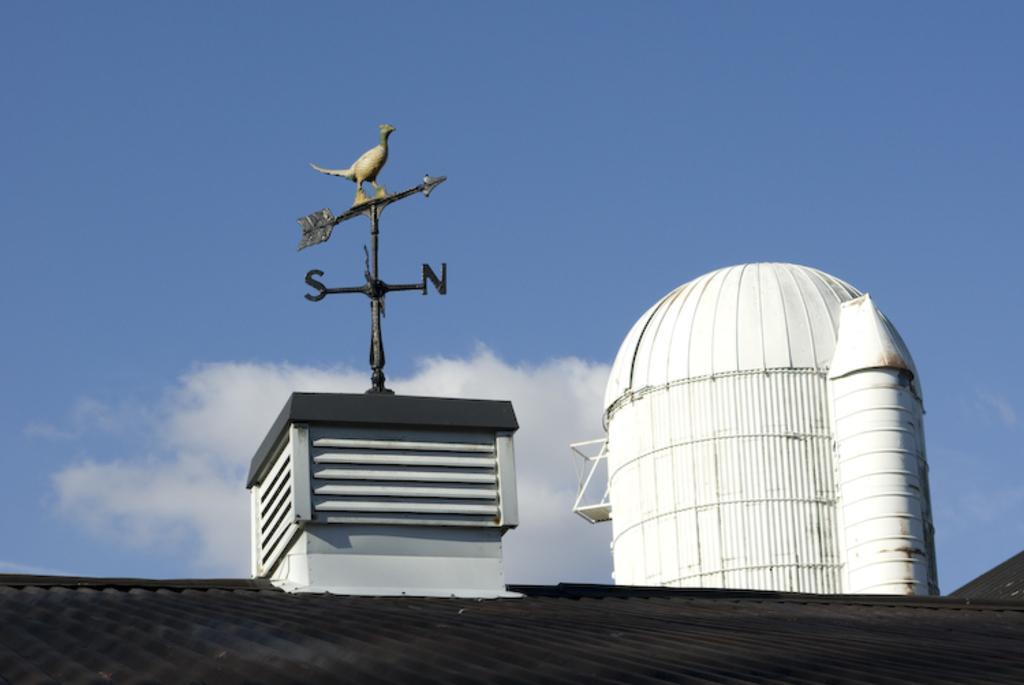How would you summarize this image in a sentence or two? In this image at the bottom there is a roof, and in the center there is some box and poles and statue. And on the right side there is a building, at the top there is sky. 